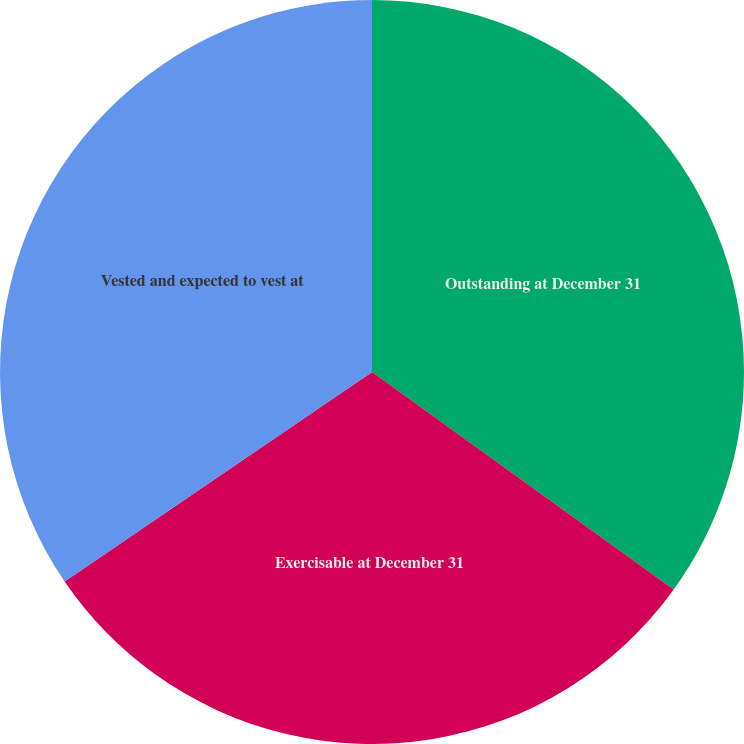Convert chart to OTSL. <chart><loc_0><loc_0><loc_500><loc_500><pie_chart><fcel>Outstanding at December 31<fcel>Exercisable at December 31<fcel>Vested and expected to vest at<nl><fcel>34.94%<fcel>30.53%<fcel>34.52%<nl></chart> 